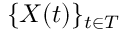Convert formula to latex. <formula><loc_0><loc_0><loc_500><loc_500>\{ X ( t ) \} _ { t \in T }</formula> 